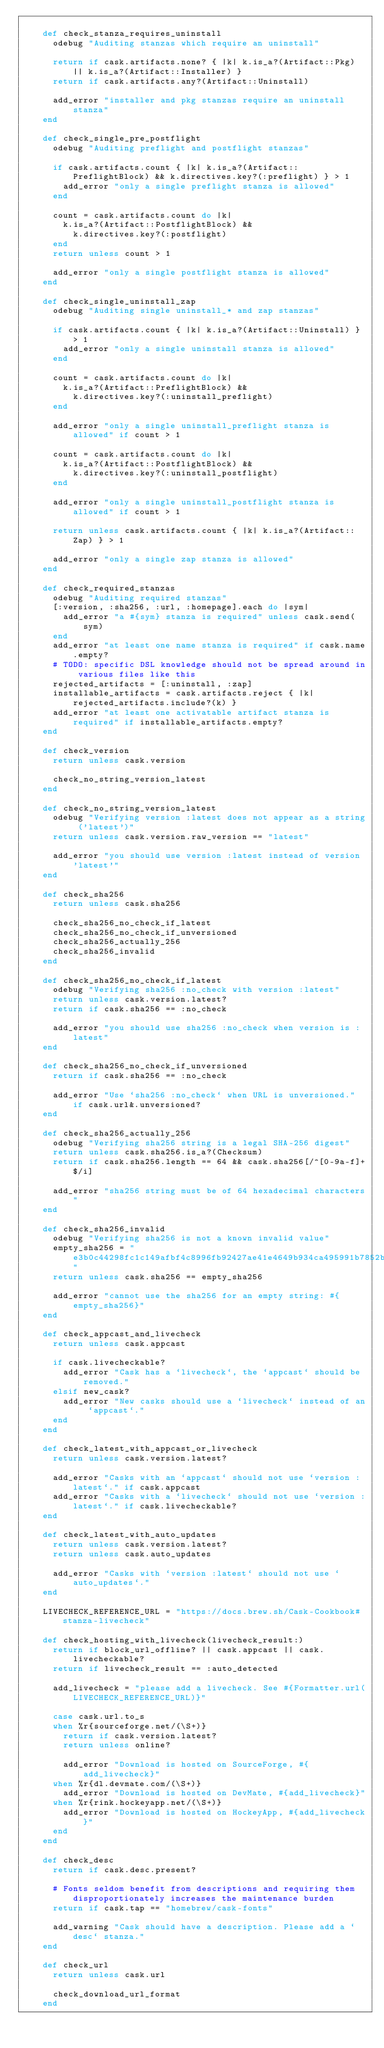<code> <loc_0><loc_0><loc_500><loc_500><_Ruby_>
    def check_stanza_requires_uninstall
      odebug "Auditing stanzas which require an uninstall"

      return if cask.artifacts.none? { |k| k.is_a?(Artifact::Pkg) || k.is_a?(Artifact::Installer) }
      return if cask.artifacts.any?(Artifact::Uninstall)

      add_error "installer and pkg stanzas require an uninstall stanza"
    end

    def check_single_pre_postflight
      odebug "Auditing preflight and postflight stanzas"

      if cask.artifacts.count { |k| k.is_a?(Artifact::PreflightBlock) && k.directives.key?(:preflight) } > 1
        add_error "only a single preflight stanza is allowed"
      end

      count = cask.artifacts.count do |k|
        k.is_a?(Artifact::PostflightBlock) &&
          k.directives.key?(:postflight)
      end
      return unless count > 1

      add_error "only a single postflight stanza is allowed"
    end

    def check_single_uninstall_zap
      odebug "Auditing single uninstall_* and zap stanzas"

      if cask.artifacts.count { |k| k.is_a?(Artifact::Uninstall) } > 1
        add_error "only a single uninstall stanza is allowed"
      end

      count = cask.artifacts.count do |k|
        k.is_a?(Artifact::PreflightBlock) &&
          k.directives.key?(:uninstall_preflight)
      end

      add_error "only a single uninstall_preflight stanza is allowed" if count > 1

      count = cask.artifacts.count do |k|
        k.is_a?(Artifact::PostflightBlock) &&
          k.directives.key?(:uninstall_postflight)
      end

      add_error "only a single uninstall_postflight stanza is allowed" if count > 1

      return unless cask.artifacts.count { |k| k.is_a?(Artifact::Zap) } > 1

      add_error "only a single zap stanza is allowed"
    end

    def check_required_stanzas
      odebug "Auditing required stanzas"
      [:version, :sha256, :url, :homepage].each do |sym|
        add_error "a #{sym} stanza is required" unless cask.send(sym)
      end
      add_error "at least one name stanza is required" if cask.name.empty?
      # TODO: specific DSL knowledge should not be spread around in various files like this
      rejected_artifacts = [:uninstall, :zap]
      installable_artifacts = cask.artifacts.reject { |k| rejected_artifacts.include?(k) }
      add_error "at least one activatable artifact stanza is required" if installable_artifacts.empty?
    end

    def check_version
      return unless cask.version

      check_no_string_version_latest
    end

    def check_no_string_version_latest
      odebug "Verifying version :latest does not appear as a string ('latest')"
      return unless cask.version.raw_version == "latest"

      add_error "you should use version :latest instead of version 'latest'"
    end

    def check_sha256
      return unless cask.sha256

      check_sha256_no_check_if_latest
      check_sha256_no_check_if_unversioned
      check_sha256_actually_256
      check_sha256_invalid
    end

    def check_sha256_no_check_if_latest
      odebug "Verifying sha256 :no_check with version :latest"
      return unless cask.version.latest?
      return if cask.sha256 == :no_check

      add_error "you should use sha256 :no_check when version is :latest"
    end

    def check_sha256_no_check_if_unversioned
      return if cask.sha256 == :no_check

      add_error "Use `sha256 :no_check` when URL is unversioned." if cask.url&.unversioned?
    end

    def check_sha256_actually_256
      odebug "Verifying sha256 string is a legal SHA-256 digest"
      return unless cask.sha256.is_a?(Checksum)
      return if cask.sha256.length == 64 && cask.sha256[/^[0-9a-f]+$/i]

      add_error "sha256 string must be of 64 hexadecimal characters"
    end

    def check_sha256_invalid
      odebug "Verifying sha256 is not a known invalid value"
      empty_sha256 = "e3b0c44298fc1c149afbf4c8996fb92427ae41e4649b934ca495991b7852b855"
      return unless cask.sha256 == empty_sha256

      add_error "cannot use the sha256 for an empty string: #{empty_sha256}"
    end

    def check_appcast_and_livecheck
      return unless cask.appcast

      if cask.livecheckable?
        add_error "Cask has a `livecheck`, the `appcast` should be removed."
      elsif new_cask?
        add_error "New casks should use a `livecheck` instead of an `appcast`."
      end
    end

    def check_latest_with_appcast_or_livecheck
      return unless cask.version.latest?

      add_error "Casks with an `appcast` should not use `version :latest`." if cask.appcast
      add_error "Casks with a `livecheck` should not use `version :latest`." if cask.livecheckable?
    end

    def check_latest_with_auto_updates
      return unless cask.version.latest?
      return unless cask.auto_updates

      add_error "Casks with `version :latest` should not use `auto_updates`."
    end

    LIVECHECK_REFERENCE_URL = "https://docs.brew.sh/Cask-Cookbook#stanza-livecheck"

    def check_hosting_with_livecheck(livecheck_result:)
      return if block_url_offline? || cask.appcast || cask.livecheckable?
      return if livecheck_result == :auto_detected

      add_livecheck = "please add a livecheck. See #{Formatter.url(LIVECHECK_REFERENCE_URL)}"

      case cask.url.to_s
      when %r{sourceforge.net/(\S+)}
        return if cask.version.latest?
        return unless online?

        add_error "Download is hosted on SourceForge, #{add_livecheck}"
      when %r{dl.devmate.com/(\S+)}
        add_error "Download is hosted on DevMate, #{add_livecheck}"
      when %r{rink.hockeyapp.net/(\S+)}
        add_error "Download is hosted on HockeyApp, #{add_livecheck}"
      end
    end

    def check_desc
      return if cask.desc.present?

      # Fonts seldom benefit from descriptions and requiring them disproportionately increases the maintenance burden
      return if cask.tap == "homebrew/cask-fonts"

      add_warning "Cask should have a description. Please add a `desc` stanza."
    end

    def check_url
      return unless cask.url

      check_download_url_format
    end
</code> 